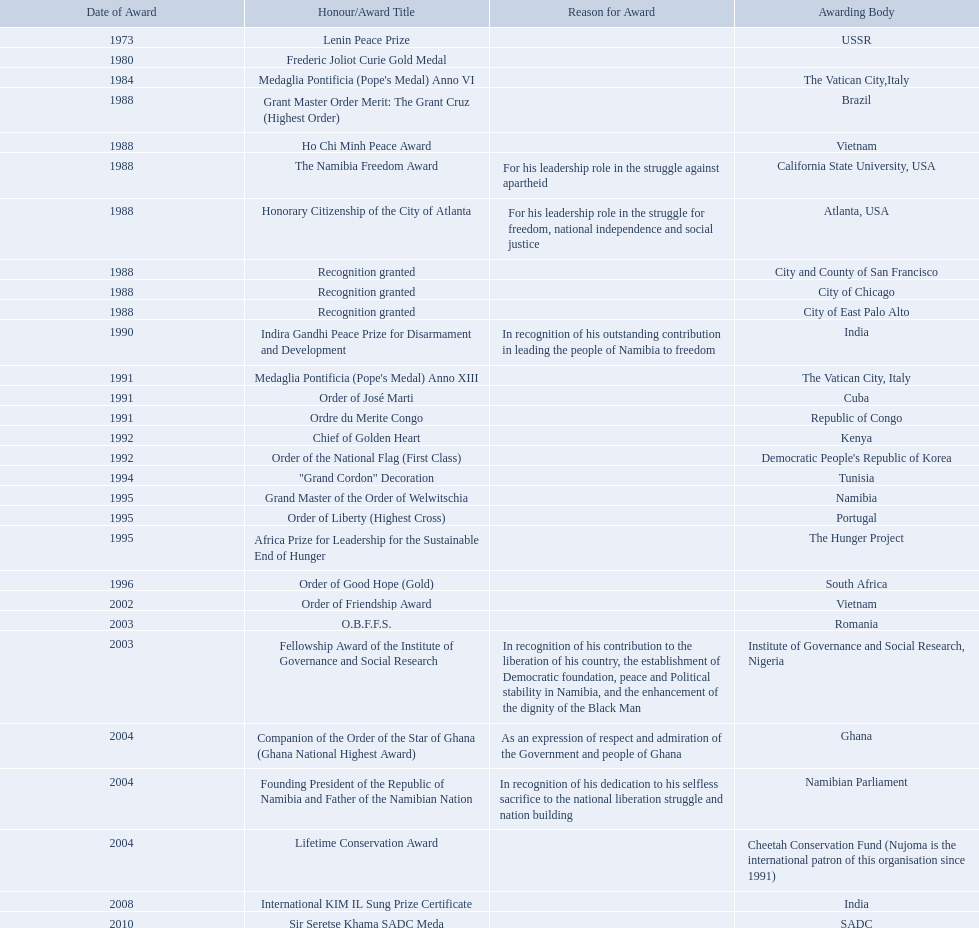Write the full table. {'header': ['Date of Award', 'Honour/Award Title', 'Reason for Award', 'Awarding Body'], 'rows': [['1973', 'Lenin Peace Prize', '', 'USSR'], ['1980', 'Frederic Joliot Curie Gold Medal', '', ''], ['1984', "Medaglia Pontificia (Pope's Medal) Anno VI", '', 'The Vatican City,Italy'], ['1988', 'Grant Master Order Merit: The Grant Cruz (Highest Order)', '', 'Brazil'], ['1988', 'Ho Chi Minh Peace Award', '', 'Vietnam'], ['1988', 'The Namibia Freedom Award', 'For his leadership role in the struggle against apartheid', 'California State University, USA'], ['1988', 'Honorary Citizenship of the City of Atlanta', 'For his leadership role in the struggle for freedom, national independence and social justice', 'Atlanta, USA'], ['1988', 'Recognition granted', '', 'City and County of San Francisco'], ['1988', 'Recognition granted', '', 'City of Chicago'], ['1988', 'Recognition granted', '', 'City of East Palo Alto'], ['1990', 'Indira Gandhi Peace Prize for Disarmament and Development', 'In recognition of his outstanding contribution in leading the people of Namibia to freedom', 'India'], ['1991', "Medaglia Pontificia (Pope's Medal) Anno XIII", '', 'The Vatican City, Italy'], ['1991', 'Order of José Marti', '', 'Cuba'], ['1991', 'Ordre du Merite Congo', '', 'Republic of Congo'], ['1992', 'Chief of Golden Heart', '', 'Kenya'], ['1992', 'Order of the National Flag (First Class)', '', "Democratic People's Republic of Korea"], ['1994', '"Grand Cordon" Decoration', '', 'Tunisia'], ['1995', 'Grand Master of the Order of Welwitschia', '', 'Namibia'], ['1995', 'Order of Liberty (Highest Cross)', '', 'Portugal'], ['1995', 'Africa Prize for Leadership for the Sustainable End of Hunger', '', 'The Hunger Project'], ['1996', 'Order of Good Hope (Gold)', '', 'South Africa'], ['2002', 'Order of Friendship Award', '', 'Vietnam'], ['2003', 'O.B.F.F.S.', '', 'Romania'], ['2003', 'Fellowship Award of the Institute of Governance and Social Research', 'In recognition of his contribution to the liberation of his country, the establishment of Democratic foundation, peace and Political stability in Namibia, and the enhancement of the dignity of the Black Man', 'Institute of Governance and Social Research, Nigeria'], ['2004', 'Companion of the Order of the Star of Ghana (Ghana National Highest Award)', 'As an expression of respect and admiration of the Government and people of Ghana', 'Ghana'], ['2004', 'Founding President of the Republic of Namibia and Father of the Namibian Nation', 'In recognition of his dedication to his selfless sacrifice to the national liberation struggle and nation building', 'Namibian Parliament'], ['2004', 'Lifetime Conservation Award', '', 'Cheetah Conservation Fund (Nujoma is the international patron of this organisation since 1991)'], ['2008', 'International KIM IL Sung Prize Certificate', '', 'India'], ['2010', 'Sir Seretse Khama SADC Meda', '', 'SADC']]} What awards has sam nujoma been awarded? Lenin Peace Prize, Frederic Joliot Curie Gold Medal, Medaglia Pontificia (Pope's Medal) Anno VI, Grant Master Order Merit: The Grant Cruz (Highest Order), Ho Chi Minh Peace Award, The Namibia Freedom Award, Honorary Citizenship of the City of Atlanta, Recognition granted, Recognition granted, Recognition granted, Indira Gandhi Peace Prize for Disarmament and Development, Medaglia Pontificia (Pope's Medal) Anno XIII, Order of José Marti, Ordre du Merite Congo, Chief of Golden Heart, Order of the National Flag (First Class), "Grand Cordon" Decoration, Grand Master of the Order of Welwitschia, Order of Liberty (Highest Cross), Africa Prize for Leadership for the Sustainable End of Hunger, Order of Good Hope (Gold), Order of Friendship Award, O.B.F.F.S., Fellowship Award of the Institute of Governance and Social Research, Companion of the Order of the Star of Ghana (Ghana National Highest Award), Founding President of the Republic of Namibia and Father of the Namibian Nation, Lifetime Conservation Award, International KIM IL Sung Prize Certificate, Sir Seretse Khama SADC Meda. By which awarding body did sam nujoma receive the o.b.f.f.s award? Romania. Which awarding bodies have recognized sam nujoma? USSR, , The Vatican City,Italy, Brazil, Vietnam, California State University, USA, Atlanta, USA, City and County of San Francisco, City of Chicago, City of East Palo Alto, India, The Vatican City, Italy, Cuba, Republic of Congo, Kenya, Democratic People's Republic of Korea, Tunisia, Namibia, Portugal, The Hunger Project, South Africa, Vietnam, Romania, Institute of Governance and Social Research, Nigeria, Ghana, Namibian Parliament, Cheetah Conservation Fund (Nujoma is the international patron of this organisation since 1991), India, SADC. And what was the title of each award or honour? Lenin Peace Prize, Frederic Joliot Curie Gold Medal, Medaglia Pontificia (Pope's Medal) Anno VI, Grant Master Order Merit: The Grant Cruz (Highest Order), Ho Chi Minh Peace Award, The Namibia Freedom Award, Honorary Citizenship of the City of Atlanta, Recognition granted, Recognition granted, Recognition granted, Indira Gandhi Peace Prize for Disarmament and Development, Medaglia Pontificia (Pope's Medal) Anno XIII, Order of José Marti, Ordre du Merite Congo, Chief of Golden Heart, Order of the National Flag (First Class), "Grand Cordon" Decoration, Grand Master of the Order of Welwitschia, Order of Liberty (Highest Cross), Africa Prize for Leadership for the Sustainable End of Hunger, Order of Good Hope (Gold), Order of Friendship Award, O.B.F.F.S., Fellowship Award of the Institute of Governance and Social Research, Companion of the Order of the Star of Ghana (Ghana National Highest Award), Founding President of the Republic of Namibia and Father of the Namibian Nation, Lifetime Conservation Award, International KIM IL Sung Prize Certificate, Sir Seretse Khama SADC Meda. Can you give me this table in json format? {'header': ['Date of Award', 'Honour/Award Title', 'Reason for Award', 'Awarding Body'], 'rows': [['1973', 'Lenin Peace Prize', '', 'USSR'], ['1980', 'Frederic Joliot Curie Gold Medal', '', ''], ['1984', "Medaglia Pontificia (Pope's Medal) Anno VI", '', 'The Vatican City,Italy'], ['1988', 'Grant Master Order Merit: The Grant Cruz (Highest Order)', '', 'Brazil'], ['1988', 'Ho Chi Minh Peace Award', '', 'Vietnam'], ['1988', 'The Namibia Freedom Award', 'For his leadership role in the struggle against apartheid', 'California State University, USA'], ['1988', 'Honorary Citizenship of the City of Atlanta', 'For his leadership role in the struggle for freedom, national independence and social justice', 'Atlanta, USA'], ['1988', 'Recognition granted', '', 'City and County of San Francisco'], ['1988', 'Recognition granted', '', 'City of Chicago'], ['1988', 'Recognition granted', '', 'City of East Palo Alto'], ['1990', 'Indira Gandhi Peace Prize for Disarmament and Development', 'In recognition of his outstanding contribution in leading the people of Namibia to freedom', 'India'], ['1991', "Medaglia Pontificia (Pope's Medal) Anno XIII", '', 'The Vatican City, Italy'], ['1991', 'Order of José Marti', '', 'Cuba'], ['1991', 'Ordre du Merite Congo', '', 'Republic of Congo'], ['1992', 'Chief of Golden Heart', '', 'Kenya'], ['1992', 'Order of the National Flag (First Class)', '', "Democratic People's Republic of Korea"], ['1994', '"Grand Cordon" Decoration', '', 'Tunisia'], ['1995', 'Grand Master of the Order of Welwitschia', '', 'Namibia'], ['1995', 'Order of Liberty (Highest Cross)', '', 'Portugal'], ['1995', 'Africa Prize for Leadership for the Sustainable End of Hunger', '', 'The Hunger Project'], ['1996', 'Order of Good Hope (Gold)', '', 'South Africa'], ['2002', 'Order of Friendship Award', '', 'Vietnam'], ['2003', 'O.B.F.F.S.', '', 'Romania'], ['2003', 'Fellowship Award of the Institute of Governance and Social Research', 'In recognition of his contribution to the liberation of his country, the establishment of Democratic foundation, peace and Political stability in Namibia, and the enhancement of the dignity of the Black Man', 'Institute of Governance and Social Research, Nigeria'], ['2004', 'Companion of the Order of the Star of Ghana (Ghana National Highest Award)', 'As an expression of respect and admiration of the Government and people of Ghana', 'Ghana'], ['2004', 'Founding President of the Republic of Namibia and Father of the Namibian Nation', 'In recognition of his dedication to his selfless sacrifice to the national liberation struggle and nation building', 'Namibian Parliament'], ['2004', 'Lifetime Conservation Award', '', 'Cheetah Conservation Fund (Nujoma is the international patron of this organisation since 1991)'], ['2008', 'International KIM IL Sung Prize Certificate', '', 'India'], ['2010', 'Sir Seretse Khama SADC Meda', '', 'SADC']]} Of those, which nation awarded him the o.b.f.f.s.? Romania. What awards did sam nujoma win? 1, 1973, Lenin Peace Prize, Frederic Joliot Curie Gold Medal, Medaglia Pontificia (Pope's Medal) Anno VI, Grant Master Order Merit: The Grant Cruz (Highest Order), Ho Chi Minh Peace Award, The Namibia Freedom Award, Honorary Citizenship of the City of Atlanta, Recognition granted, Recognition granted, Recognition granted, Indira Gandhi Peace Prize for Disarmament and Development, Medaglia Pontificia (Pope's Medal) Anno XIII, Order of José Marti, Ordre du Merite Congo, Chief of Golden Heart, Order of the National Flag (First Class), "Grand Cordon" Decoration, Grand Master of the Order of Welwitschia, Order of Liberty (Highest Cross), Africa Prize for Leadership for the Sustainable End of Hunger, Order of Good Hope (Gold), Order of Friendship Award, O.B.F.F.S., Fellowship Award of the Institute of Governance and Social Research, Companion of the Order of the Star of Ghana (Ghana National Highest Award), Founding President of the Republic of Namibia and Father of the Namibian Nation, Lifetime Conservation Award, International KIM IL Sung Prize Certificate, Sir Seretse Khama SADC Meda. Who was the awarding body for the o.b.f.f.s award? Romania. 